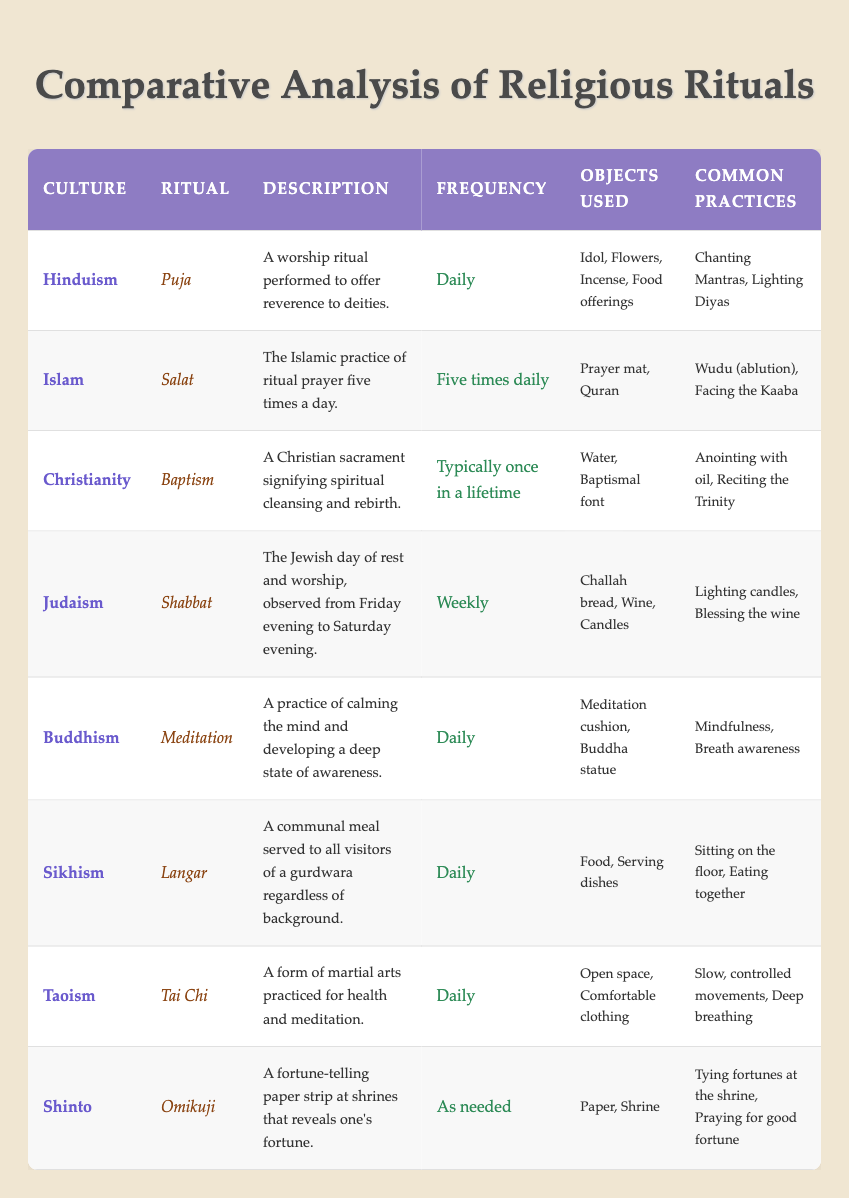What is the daily ritual of Hinduism? The table shows that the daily ritual in Hinduism is "Puja", which is described as a worship ritual performed to offer reverence to deities.
Answer: Puja How often is the ritual of Salat practiced in Islam? The table indicates that Salat, the Islamic practice of ritual prayer, is performed five times daily.
Answer: Five times daily Which cultures practice their rituals daily? By examining the frequency column, Hinduism, Buddhism, Sikhism, and Taoism are listed as having daily rituals: Puja, Meditation, Langar, and Tai Chi, respectively.
Answer: Hinduism, Buddhism, Sikhism, Taoism What objects are used during the Christian ritual of Baptism? The objects used during baptism according to the table are Water and a Baptismal font.
Answer: Water, Baptismal font Does Judaism observe Shabbat weekly? The table explicitly states that Shabbat is observed weekly, which confirms the fact.
Answer: Yes Which ritual involves communal meals? The table shows that "Langar" in Sikhism involves communal meals served to all visitors of a gurdwara.
Answer: Langar Is the frequency of the Omikuji ritual in Shinto consistent? The table notes that Omikuji is performed as needed, indicating it does not follow a fixed schedule.
Answer: No How many different objects are used in the ritual of Puja in Hinduism? The table lists four objects used in the Hindu ritual of Puja: Idol, Flowers, Incense, and Food offerings. Counting these, we find there are four total objects listed.
Answer: Four Which two rituals have a similar frequency of being performed daily? By comparing the frequency column, both "Meditation" in Buddhism and "Puja" in Hinduism are performed daily.
Answer: Meditation, Puja What is the main purpose of Baptism in Christianity, according to the table? The table describes Baptism as a sacrament signifying spiritual cleansing and rebirth, which defines its main purpose.
Answer: Spiritual cleansing and rebirth How do the common practices of Langar in Sikhism emphasize community? The table indicates that Langar involves practices such as sitting on the floor and eating together, which fosters a sense of community and equality among participants.
Answer: They emphasize community through shared meals and seating arrangements Which culture's rituals involve fortune-telling? The table identifies the Shinto ritual "Omikuji" as involving fortune-telling, as it reveals one’s fortune through a paper strip at shrines.
Answer: Shinto 